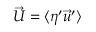Convert formula to latex. <formula><loc_0><loc_0><loc_500><loc_500>\vec { U } = \langle \eta ^ { \prime } \vec { u } ^ { \prime } \rangle</formula> 